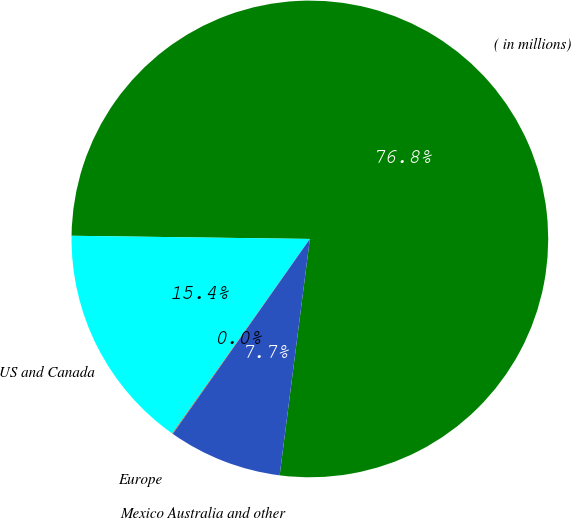<chart> <loc_0><loc_0><loc_500><loc_500><pie_chart><fcel>( in millions)<fcel>US and Canada<fcel>Europe<fcel>Mexico Australia and other<nl><fcel>76.81%<fcel>15.41%<fcel>0.05%<fcel>7.73%<nl></chart> 